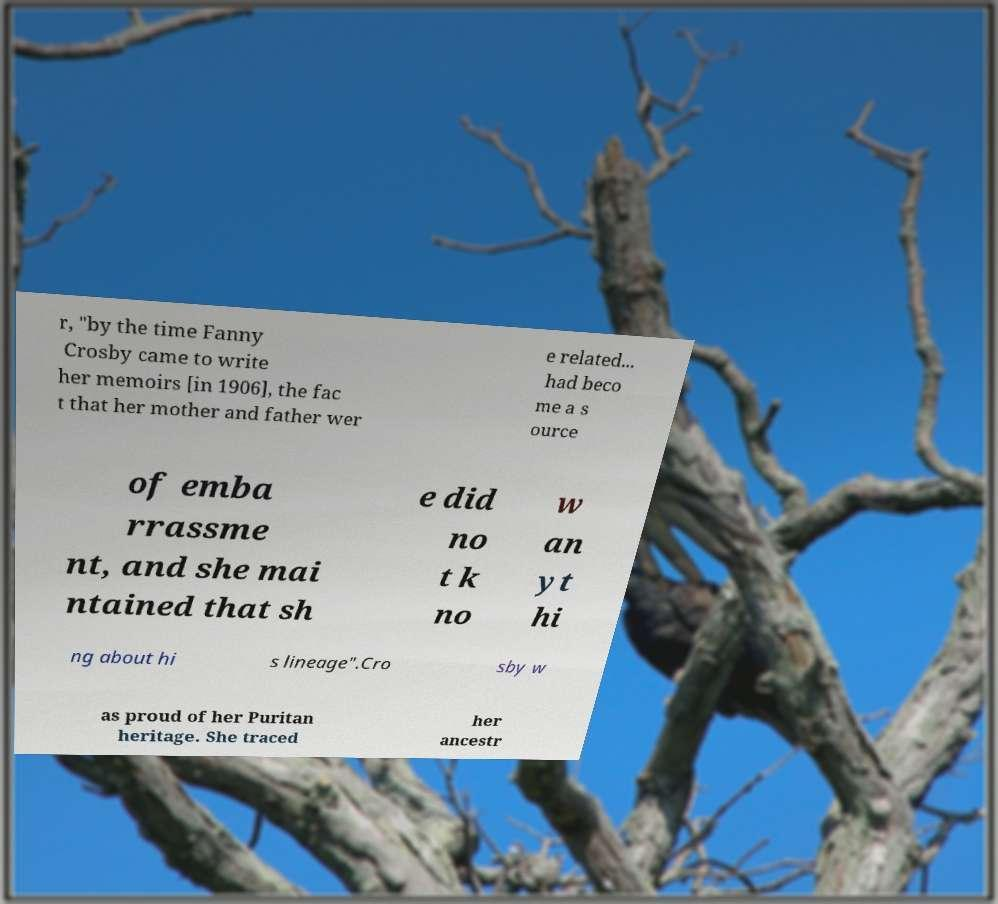Please read and relay the text visible in this image. What does it say? r, "by the time Fanny Crosby came to write her memoirs [in 1906], the fac t that her mother and father wer e related... had beco me a s ource of emba rrassme nt, and she mai ntained that sh e did no t k no w an yt hi ng about hi s lineage".Cro sby w as proud of her Puritan heritage. She traced her ancestr 